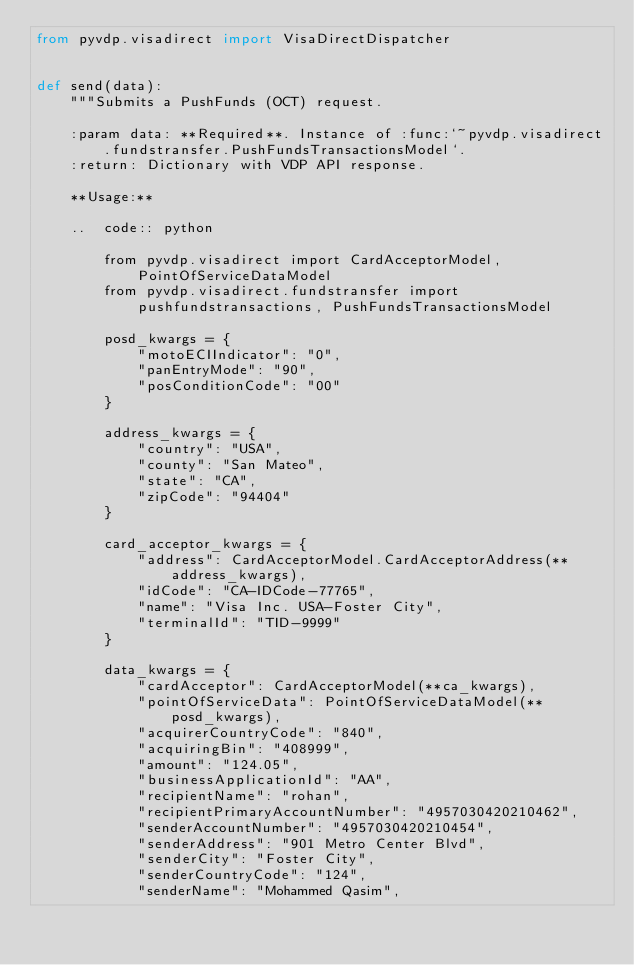Convert code to text. <code><loc_0><loc_0><loc_500><loc_500><_Python_>from pyvdp.visadirect import VisaDirectDispatcher


def send(data):
    """Submits a PushFunds (OCT) request.

    :param data: **Required**. Instance of :func:`~pyvdp.visadirect.fundstransfer.PushFundsTransactionsModel`.
    :return: Dictionary with VDP API response.
    
    **Usage:**
    
    ..  code:: python
    
        from pyvdp.visadirect import CardAcceptorModel, PointOfServiceDataModel
        from pyvdp.visadirect.fundstransfer import pushfundstransactions, PushFundsTransactionsModel
        
        posd_kwargs = {
            "motoECIIndicator": "0",
            "panEntryMode": "90",
            "posConditionCode": "00"            
        }
             
        address_kwargs = {
            "country": "USA",
            "county": "San Mateo",
            "state": "CA",
            "zipCode": "94404"        
        }
        
        card_acceptor_kwargs = {
            "address": CardAcceptorModel.CardAcceptorAddress(**address_kwargs),
            "idCode": "CA-IDCode-77765",
            "name": "Visa Inc. USA-Foster City",
            "terminalId": "TID-9999"        
        }
        
        data_kwargs = {
            "cardAcceptor": CardAcceptorModel(**ca_kwargs),
            "pointOfServiceData": PointOfServiceDataModel(**posd_kwargs),
            "acquirerCountryCode": "840",
            "acquiringBin": "408999",
            "amount": "124.05",
            "businessApplicationId": "AA",
            "recipientName": "rohan",
            "recipientPrimaryAccountNumber": "4957030420210462",
            "senderAccountNumber": "4957030420210454",
            "senderAddress": "901 Metro Center Blvd",
            "senderCity": "Foster City",
            "senderCountryCode": "124",
            "senderName": "Mohammed Qasim",</code> 